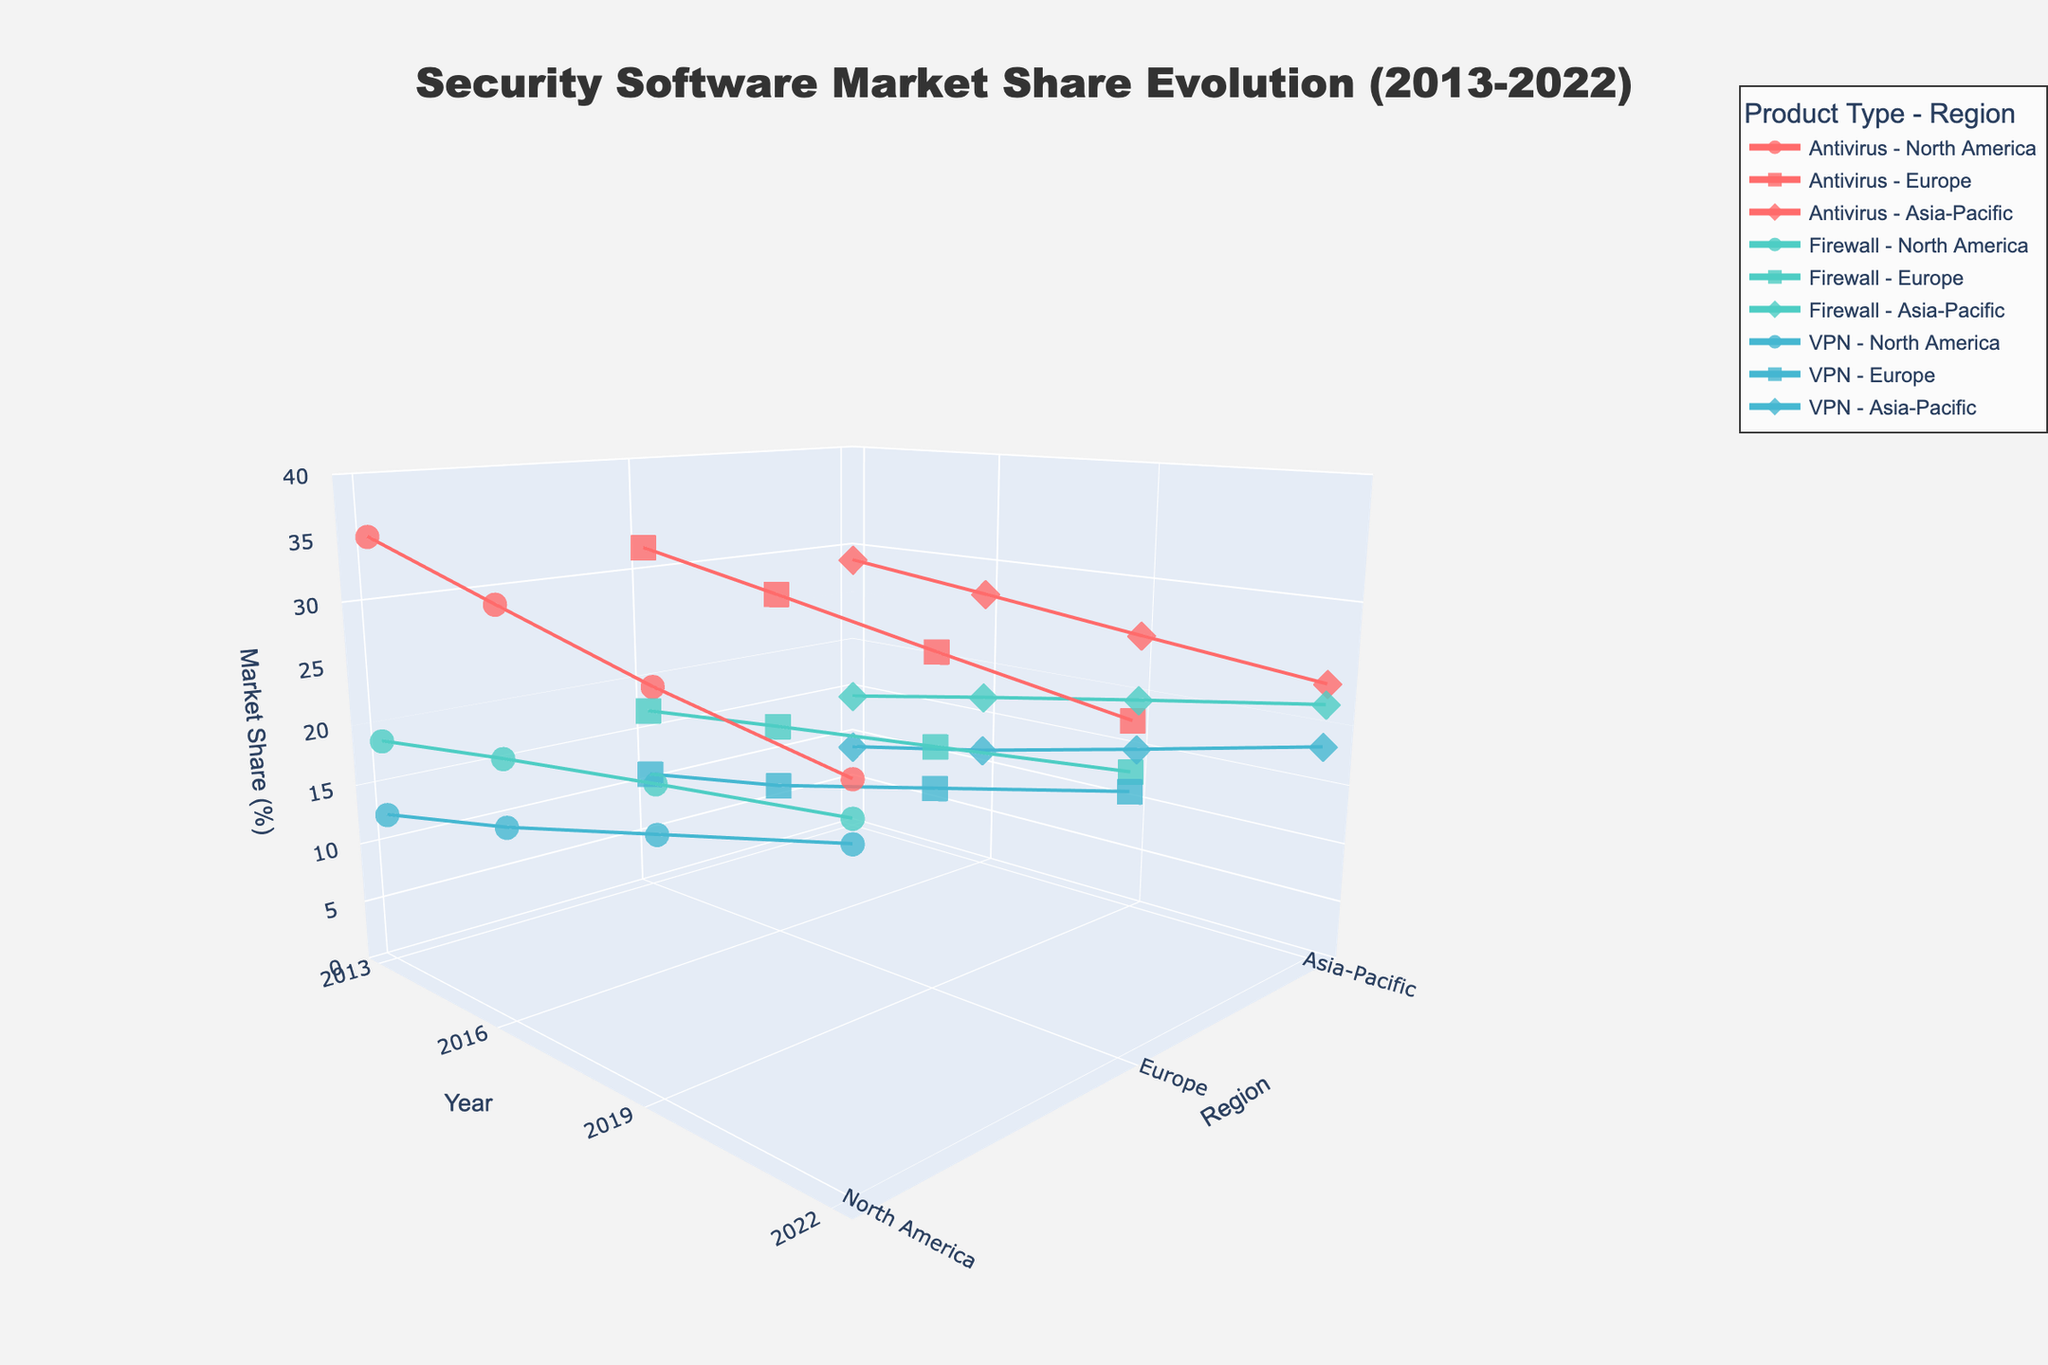What's the title of the plot? The title of the plot usually appears at the top center. In this case, it is "Security Software Market Share Evolution (2013-2022)".
Answer: Security Software Market Share Evolution (2013-2022) What are the X, Y, and Z axes representing in the plot? By examining the axis titles, we can identify what each axis represents. The X-axis represents the "Year", the Y-axis represents the "Region", and the Z-axis represents the "Market Share (%)".
Answer: Year, Region, Market Share (%) Which product type has the highest market share in North America in 2022? We need to look for the data points for North America in 2022 and compare the market shares among all product types. The highest market share is for VPN at 22.1%.
Answer: VPN How did the market share of Firewalls in Europe trend from 2013 to 2022? To determine the trend, we follow the data points for Firewalls in Europe across the years. The market share increased from 16.9% in 2013 to 18.4% in 2016, 19.8% in 2019, and 21.2% in 2022.
Answer: Increasing Which product type saw the greatest increase in market share in the Asia-Pacific region from 2013 to 2022? We calculate the difference in market share for each product type in the Asia-Pacific region between 2013 and 2022. Antivirus: 23.4-28.6 = -5.2, Firewall: 21.7-14.2 = 7.5, VPN: 18.2-8.7 = 9.5. VPN saw the greatest increase.
Answer: VPN Compare the market shares of Antivirus software in 2013 and 2022 for all regions. How do they differ? We check the Antivirus market share for 2013 and 2022 in each region. North America: 35.2% to 25.9%, Europe: 32.1% to 24.8%, Asia-Pacific: 28.6% to 23.4%. All regions experienced a decline in Antivirus market share.
Answer: All regions declined In 2019, which region had the lowest market share for VPNs? By comparing the market shares of VPNs in different regions for the year 2019, Asia-Pacific had the lowest value at 14.8%.
Answer: Asia-Pacific What's the average market share of Firewalls in Europe across all reported years? We sum the market shares of Firewalls in Europe for the years (16.9 + 18.4 + 19.8 + 21.2) and divide by the number of years (4). The average market share is (16.9 + 18.4 + 19.8 + 21.2)/4 = 19.075.
Answer: 19.075% Which region showed the least variation in Antivirus market share from 2013 to 2022? To find the least variation, compare the market share range in each region. North America: 35.2-25.9=9.3, Europe: 32.1-24.8=7.3, Asia-Pacific: 28.6-23.4=5.2. Asia-Pacific showed the least variation.
Answer: Asia-Pacific 